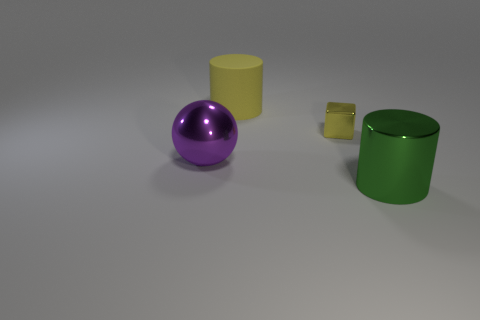Add 1 large cyan metal cylinders. How many objects exist? 5 Subtract all blocks. How many objects are left? 3 Subtract all blue rubber blocks. Subtract all big rubber cylinders. How many objects are left? 3 Add 3 purple balls. How many purple balls are left? 4 Add 2 purple metal spheres. How many purple metal spheres exist? 3 Subtract 0 blue cubes. How many objects are left? 4 